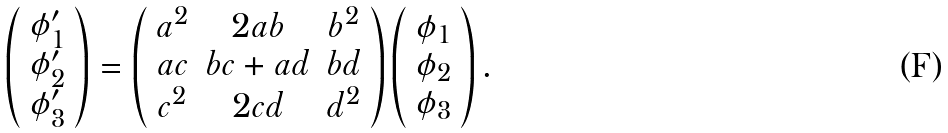Convert formula to latex. <formula><loc_0><loc_0><loc_500><loc_500>\left ( \begin{array} { c } \phi ^ { \prime } _ { 1 } \\ \phi ^ { \prime } _ { 2 } \\ \phi ^ { \prime } _ { 3 } \\ \end{array} \right ) = \left ( \begin{array} { c c c } a ^ { 2 } & 2 a b & b ^ { 2 } \\ a c & b c + a d & b d \\ c ^ { 2 } & 2 c d & d ^ { 2 } \\ \end{array} \right ) \left ( \begin{array} { c } \phi _ { 1 } \\ \phi _ { 2 } \\ \phi _ { 3 } \\ \end{array} \right ) .</formula> 